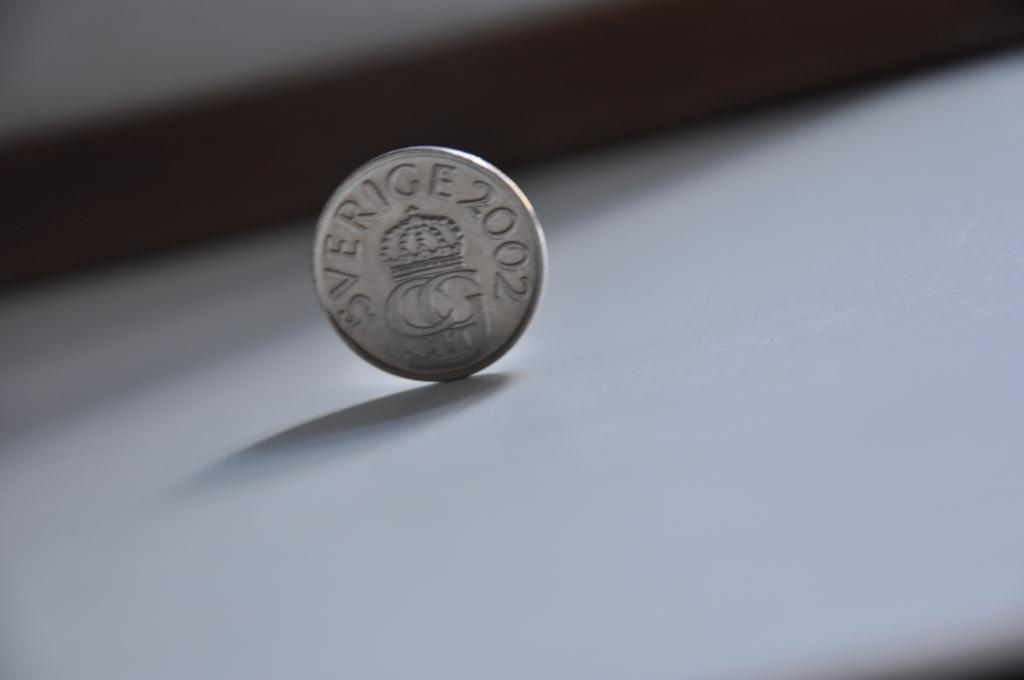<image>
Provide a brief description of the given image. A silver color coin standing on its edge dated 2002. 